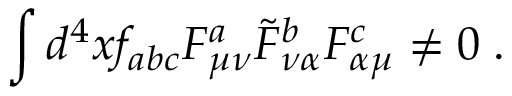Convert formula to latex. <formula><loc_0><loc_0><loc_500><loc_500>\int d ^ { 4 } x f _ { a b c } F _ { \mu \nu } ^ { a } \tilde { F } _ { \nu \alpha } ^ { b } F _ { \alpha \mu } ^ { c } \ne 0 \, .</formula> 